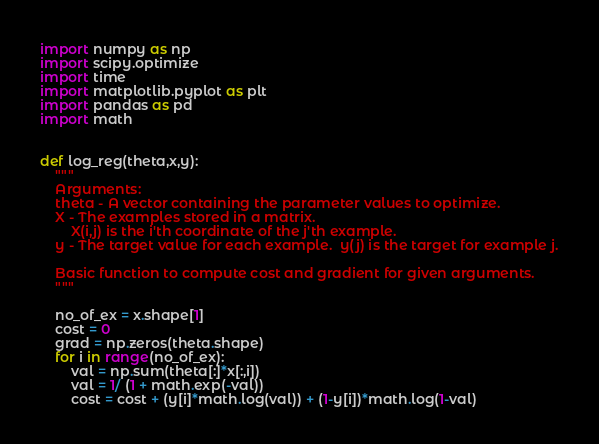Convert code to text. <code><loc_0><loc_0><loc_500><loc_500><_Python_>import numpy as np 
import scipy.optimize
import time 
import matplotlib.pyplot as plt 
import pandas as pd 
import math


def log_reg(theta,x,y):
    """
    Arguments:
    theta - A vector containing the parameter values to optimize.
    X - The examples stored in a matrix.
        X(i,j) is the i'th coordinate of the j'th example.
    y - The target value for each example.  y(j) is the target for example j.
    
    Basic function to compute cost and gradient for given arguments. 
    """

    no_of_ex = x.shape[1]
    cost = 0
    grad = np.zeros(theta.shape)
    for i in range(no_of_ex):
        val = np.sum(theta[:]*x[:,i])
        val = 1/ (1 + math.exp(-val)) 
        cost = cost + (y[i]*math.log(val)) + (1-y[i])*math.log(1-val)</code> 